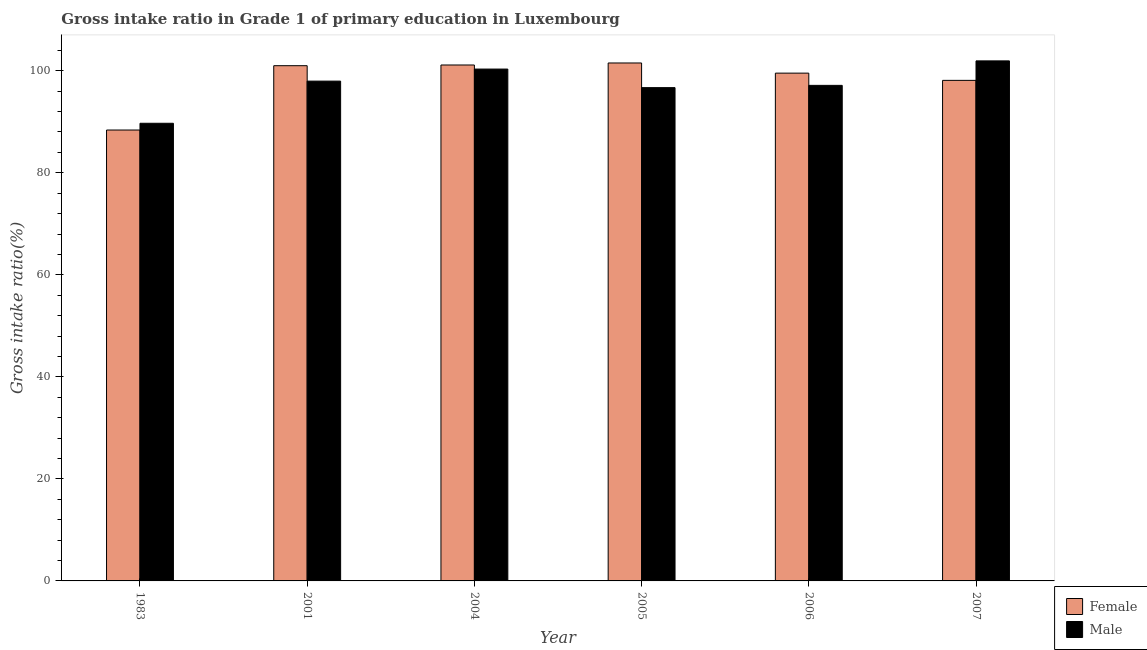How many different coloured bars are there?
Your answer should be compact. 2. How many groups of bars are there?
Make the answer very short. 6. Are the number of bars per tick equal to the number of legend labels?
Make the answer very short. Yes. What is the gross intake ratio(female) in 1983?
Make the answer very short. 88.39. Across all years, what is the maximum gross intake ratio(female)?
Your answer should be compact. 101.53. Across all years, what is the minimum gross intake ratio(female)?
Make the answer very short. 88.39. In which year was the gross intake ratio(female) maximum?
Make the answer very short. 2005. In which year was the gross intake ratio(male) minimum?
Give a very brief answer. 1983. What is the total gross intake ratio(female) in the graph?
Your response must be concise. 589.71. What is the difference between the gross intake ratio(female) in 1983 and that in 2004?
Keep it short and to the point. -12.75. What is the difference between the gross intake ratio(male) in 2001 and the gross intake ratio(female) in 2007?
Offer a very short reply. -3.97. What is the average gross intake ratio(female) per year?
Provide a succinct answer. 98.28. In how many years, is the gross intake ratio(male) greater than 24 %?
Offer a terse response. 6. What is the ratio of the gross intake ratio(female) in 2006 to that in 2007?
Give a very brief answer. 1.01. Is the difference between the gross intake ratio(male) in 1983 and 2001 greater than the difference between the gross intake ratio(female) in 1983 and 2001?
Your answer should be very brief. No. What is the difference between the highest and the second highest gross intake ratio(male)?
Give a very brief answer. 1.61. What is the difference between the highest and the lowest gross intake ratio(male)?
Keep it short and to the point. 12.23. In how many years, is the gross intake ratio(female) greater than the average gross intake ratio(female) taken over all years?
Provide a short and direct response. 4. Is the sum of the gross intake ratio(male) in 2001 and 2007 greater than the maximum gross intake ratio(female) across all years?
Your answer should be very brief. Yes. Are all the bars in the graph horizontal?
Your answer should be compact. No. What is the difference between two consecutive major ticks on the Y-axis?
Provide a succinct answer. 20. Are the values on the major ticks of Y-axis written in scientific E-notation?
Ensure brevity in your answer.  No. Does the graph contain any zero values?
Your answer should be very brief. No. How many legend labels are there?
Provide a short and direct response. 2. What is the title of the graph?
Give a very brief answer. Gross intake ratio in Grade 1 of primary education in Luxembourg. Does "Merchandise exports" appear as one of the legend labels in the graph?
Keep it short and to the point. No. What is the label or title of the Y-axis?
Offer a very short reply. Gross intake ratio(%). What is the Gross intake ratio(%) of Female in 1983?
Offer a very short reply. 88.39. What is the Gross intake ratio(%) of Male in 1983?
Offer a terse response. 89.71. What is the Gross intake ratio(%) in Female in 2001?
Ensure brevity in your answer.  101. What is the Gross intake ratio(%) in Male in 2001?
Offer a terse response. 97.97. What is the Gross intake ratio(%) in Female in 2004?
Offer a very short reply. 101.13. What is the Gross intake ratio(%) in Male in 2004?
Make the answer very short. 100.34. What is the Gross intake ratio(%) in Female in 2005?
Make the answer very short. 101.53. What is the Gross intake ratio(%) of Male in 2005?
Ensure brevity in your answer.  96.7. What is the Gross intake ratio(%) of Female in 2006?
Give a very brief answer. 99.54. What is the Gross intake ratio(%) in Male in 2006?
Provide a succinct answer. 97.14. What is the Gross intake ratio(%) of Female in 2007?
Offer a very short reply. 98.12. What is the Gross intake ratio(%) in Male in 2007?
Your answer should be compact. 101.94. Across all years, what is the maximum Gross intake ratio(%) in Female?
Your answer should be compact. 101.53. Across all years, what is the maximum Gross intake ratio(%) in Male?
Make the answer very short. 101.94. Across all years, what is the minimum Gross intake ratio(%) of Female?
Give a very brief answer. 88.39. Across all years, what is the minimum Gross intake ratio(%) of Male?
Your answer should be compact. 89.71. What is the total Gross intake ratio(%) in Female in the graph?
Make the answer very short. 589.71. What is the total Gross intake ratio(%) of Male in the graph?
Provide a short and direct response. 583.8. What is the difference between the Gross intake ratio(%) of Female in 1983 and that in 2001?
Your answer should be compact. -12.61. What is the difference between the Gross intake ratio(%) in Male in 1983 and that in 2001?
Give a very brief answer. -8.26. What is the difference between the Gross intake ratio(%) of Female in 1983 and that in 2004?
Keep it short and to the point. -12.75. What is the difference between the Gross intake ratio(%) of Male in 1983 and that in 2004?
Make the answer very short. -10.62. What is the difference between the Gross intake ratio(%) in Female in 1983 and that in 2005?
Provide a short and direct response. -13.14. What is the difference between the Gross intake ratio(%) of Male in 1983 and that in 2005?
Provide a succinct answer. -6.99. What is the difference between the Gross intake ratio(%) of Female in 1983 and that in 2006?
Your answer should be very brief. -11.15. What is the difference between the Gross intake ratio(%) of Male in 1983 and that in 2006?
Your answer should be compact. -7.43. What is the difference between the Gross intake ratio(%) of Female in 1983 and that in 2007?
Provide a short and direct response. -9.73. What is the difference between the Gross intake ratio(%) of Male in 1983 and that in 2007?
Your response must be concise. -12.23. What is the difference between the Gross intake ratio(%) of Female in 2001 and that in 2004?
Ensure brevity in your answer.  -0.14. What is the difference between the Gross intake ratio(%) in Male in 2001 and that in 2004?
Your response must be concise. -2.36. What is the difference between the Gross intake ratio(%) in Female in 2001 and that in 2005?
Provide a short and direct response. -0.53. What is the difference between the Gross intake ratio(%) in Male in 2001 and that in 2005?
Your response must be concise. 1.28. What is the difference between the Gross intake ratio(%) of Female in 2001 and that in 2006?
Your answer should be compact. 1.46. What is the difference between the Gross intake ratio(%) of Male in 2001 and that in 2006?
Offer a terse response. 0.83. What is the difference between the Gross intake ratio(%) in Female in 2001 and that in 2007?
Make the answer very short. 2.87. What is the difference between the Gross intake ratio(%) in Male in 2001 and that in 2007?
Offer a terse response. -3.97. What is the difference between the Gross intake ratio(%) in Female in 2004 and that in 2005?
Make the answer very short. -0.4. What is the difference between the Gross intake ratio(%) of Male in 2004 and that in 2005?
Keep it short and to the point. 3.64. What is the difference between the Gross intake ratio(%) in Female in 2004 and that in 2006?
Provide a short and direct response. 1.6. What is the difference between the Gross intake ratio(%) of Male in 2004 and that in 2006?
Your response must be concise. 3.2. What is the difference between the Gross intake ratio(%) of Female in 2004 and that in 2007?
Your answer should be very brief. 3.01. What is the difference between the Gross intake ratio(%) of Male in 2004 and that in 2007?
Provide a succinct answer. -1.61. What is the difference between the Gross intake ratio(%) of Female in 2005 and that in 2006?
Ensure brevity in your answer.  1.99. What is the difference between the Gross intake ratio(%) in Male in 2005 and that in 2006?
Make the answer very short. -0.44. What is the difference between the Gross intake ratio(%) in Female in 2005 and that in 2007?
Your answer should be compact. 3.41. What is the difference between the Gross intake ratio(%) in Male in 2005 and that in 2007?
Provide a short and direct response. -5.24. What is the difference between the Gross intake ratio(%) of Female in 2006 and that in 2007?
Give a very brief answer. 1.42. What is the difference between the Gross intake ratio(%) of Male in 2006 and that in 2007?
Offer a terse response. -4.8. What is the difference between the Gross intake ratio(%) of Female in 1983 and the Gross intake ratio(%) of Male in 2001?
Offer a terse response. -9.59. What is the difference between the Gross intake ratio(%) in Female in 1983 and the Gross intake ratio(%) in Male in 2004?
Offer a very short reply. -11.95. What is the difference between the Gross intake ratio(%) in Female in 1983 and the Gross intake ratio(%) in Male in 2005?
Offer a terse response. -8.31. What is the difference between the Gross intake ratio(%) of Female in 1983 and the Gross intake ratio(%) of Male in 2006?
Your response must be concise. -8.75. What is the difference between the Gross intake ratio(%) of Female in 1983 and the Gross intake ratio(%) of Male in 2007?
Your response must be concise. -13.55. What is the difference between the Gross intake ratio(%) in Female in 2001 and the Gross intake ratio(%) in Male in 2004?
Provide a short and direct response. 0.66. What is the difference between the Gross intake ratio(%) in Female in 2001 and the Gross intake ratio(%) in Male in 2005?
Your answer should be very brief. 4.3. What is the difference between the Gross intake ratio(%) in Female in 2001 and the Gross intake ratio(%) in Male in 2006?
Offer a very short reply. 3.86. What is the difference between the Gross intake ratio(%) of Female in 2001 and the Gross intake ratio(%) of Male in 2007?
Provide a succinct answer. -0.94. What is the difference between the Gross intake ratio(%) of Female in 2004 and the Gross intake ratio(%) of Male in 2005?
Offer a terse response. 4.44. What is the difference between the Gross intake ratio(%) in Female in 2004 and the Gross intake ratio(%) in Male in 2006?
Give a very brief answer. 3.99. What is the difference between the Gross intake ratio(%) in Female in 2004 and the Gross intake ratio(%) in Male in 2007?
Your answer should be compact. -0.81. What is the difference between the Gross intake ratio(%) of Female in 2005 and the Gross intake ratio(%) of Male in 2006?
Your answer should be very brief. 4.39. What is the difference between the Gross intake ratio(%) of Female in 2005 and the Gross intake ratio(%) of Male in 2007?
Give a very brief answer. -0.41. What is the difference between the Gross intake ratio(%) in Female in 2006 and the Gross intake ratio(%) in Male in 2007?
Ensure brevity in your answer.  -2.4. What is the average Gross intake ratio(%) in Female per year?
Keep it short and to the point. 98.28. What is the average Gross intake ratio(%) of Male per year?
Ensure brevity in your answer.  97.3. In the year 1983, what is the difference between the Gross intake ratio(%) in Female and Gross intake ratio(%) in Male?
Offer a terse response. -1.32. In the year 2001, what is the difference between the Gross intake ratio(%) of Female and Gross intake ratio(%) of Male?
Make the answer very short. 3.02. In the year 2004, what is the difference between the Gross intake ratio(%) in Female and Gross intake ratio(%) in Male?
Keep it short and to the point. 0.8. In the year 2005, what is the difference between the Gross intake ratio(%) in Female and Gross intake ratio(%) in Male?
Offer a very short reply. 4.83. In the year 2006, what is the difference between the Gross intake ratio(%) in Female and Gross intake ratio(%) in Male?
Make the answer very short. 2.4. In the year 2007, what is the difference between the Gross intake ratio(%) in Female and Gross intake ratio(%) in Male?
Your response must be concise. -3.82. What is the ratio of the Gross intake ratio(%) in Female in 1983 to that in 2001?
Provide a short and direct response. 0.88. What is the ratio of the Gross intake ratio(%) of Male in 1983 to that in 2001?
Your answer should be compact. 0.92. What is the ratio of the Gross intake ratio(%) of Female in 1983 to that in 2004?
Make the answer very short. 0.87. What is the ratio of the Gross intake ratio(%) in Male in 1983 to that in 2004?
Make the answer very short. 0.89. What is the ratio of the Gross intake ratio(%) in Female in 1983 to that in 2005?
Give a very brief answer. 0.87. What is the ratio of the Gross intake ratio(%) of Male in 1983 to that in 2005?
Ensure brevity in your answer.  0.93. What is the ratio of the Gross intake ratio(%) of Female in 1983 to that in 2006?
Offer a terse response. 0.89. What is the ratio of the Gross intake ratio(%) of Male in 1983 to that in 2006?
Give a very brief answer. 0.92. What is the ratio of the Gross intake ratio(%) of Female in 1983 to that in 2007?
Your answer should be very brief. 0.9. What is the ratio of the Gross intake ratio(%) of Male in 2001 to that in 2004?
Make the answer very short. 0.98. What is the ratio of the Gross intake ratio(%) of Female in 2001 to that in 2005?
Offer a terse response. 0.99. What is the ratio of the Gross intake ratio(%) of Male in 2001 to that in 2005?
Your answer should be very brief. 1.01. What is the ratio of the Gross intake ratio(%) of Female in 2001 to that in 2006?
Your answer should be compact. 1.01. What is the ratio of the Gross intake ratio(%) of Male in 2001 to that in 2006?
Your response must be concise. 1.01. What is the ratio of the Gross intake ratio(%) in Female in 2001 to that in 2007?
Provide a short and direct response. 1.03. What is the ratio of the Gross intake ratio(%) of Male in 2001 to that in 2007?
Provide a short and direct response. 0.96. What is the ratio of the Gross intake ratio(%) in Male in 2004 to that in 2005?
Keep it short and to the point. 1.04. What is the ratio of the Gross intake ratio(%) in Male in 2004 to that in 2006?
Provide a short and direct response. 1.03. What is the ratio of the Gross intake ratio(%) in Female in 2004 to that in 2007?
Make the answer very short. 1.03. What is the ratio of the Gross intake ratio(%) of Male in 2004 to that in 2007?
Provide a succinct answer. 0.98. What is the ratio of the Gross intake ratio(%) of Female in 2005 to that in 2006?
Offer a very short reply. 1.02. What is the ratio of the Gross intake ratio(%) in Female in 2005 to that in 2007?
Provide a succinct answer. 1.03. What is the ratio of the Gross intake ratio(%) of Male in 2005 to that in 2007?
Give a very brief answer. 0.95. What is the ratio of the Gross intake ratio(%) of Female in 2006 to that in 2007?
Keep it short and to the point. 1.01. What is the ratio of the Gross intake ratio(%) of Male in 2006 to that in 2007?
Offer a terse response. 0.95. What is the difference between the highest and the second highest Gross intake ratio(%) in Female?
Provide a succinct answer. 0.4. What is the difference between the highest and the second highest Gross intake ratio(%) of Male?
Keep it short and to the point. 1.61. What is the difference between the highest and the lowest Gross intake ratio(%) of Female?
Make the answer very short. 13.14. What is the difference between the highest and the lowest Gross intake ratio(%) of Male?
Make the answer very short. 12.23. 